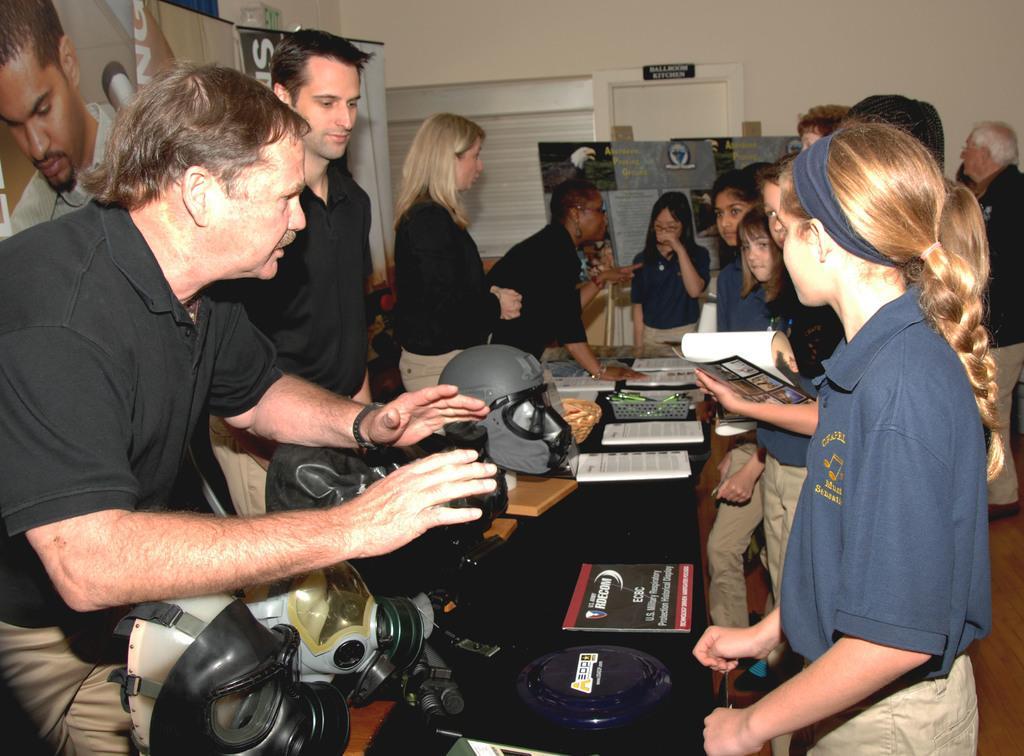Can you describe this image briefly? This is an inside view of a room. Here I can see few people are standing around the table. On the table few books, helmet, basket and some devices are placed. On the left side there is a man wearing black color t-shirt and standing. It seems like he is speaking. In the background, I can see few posts to the wall. 